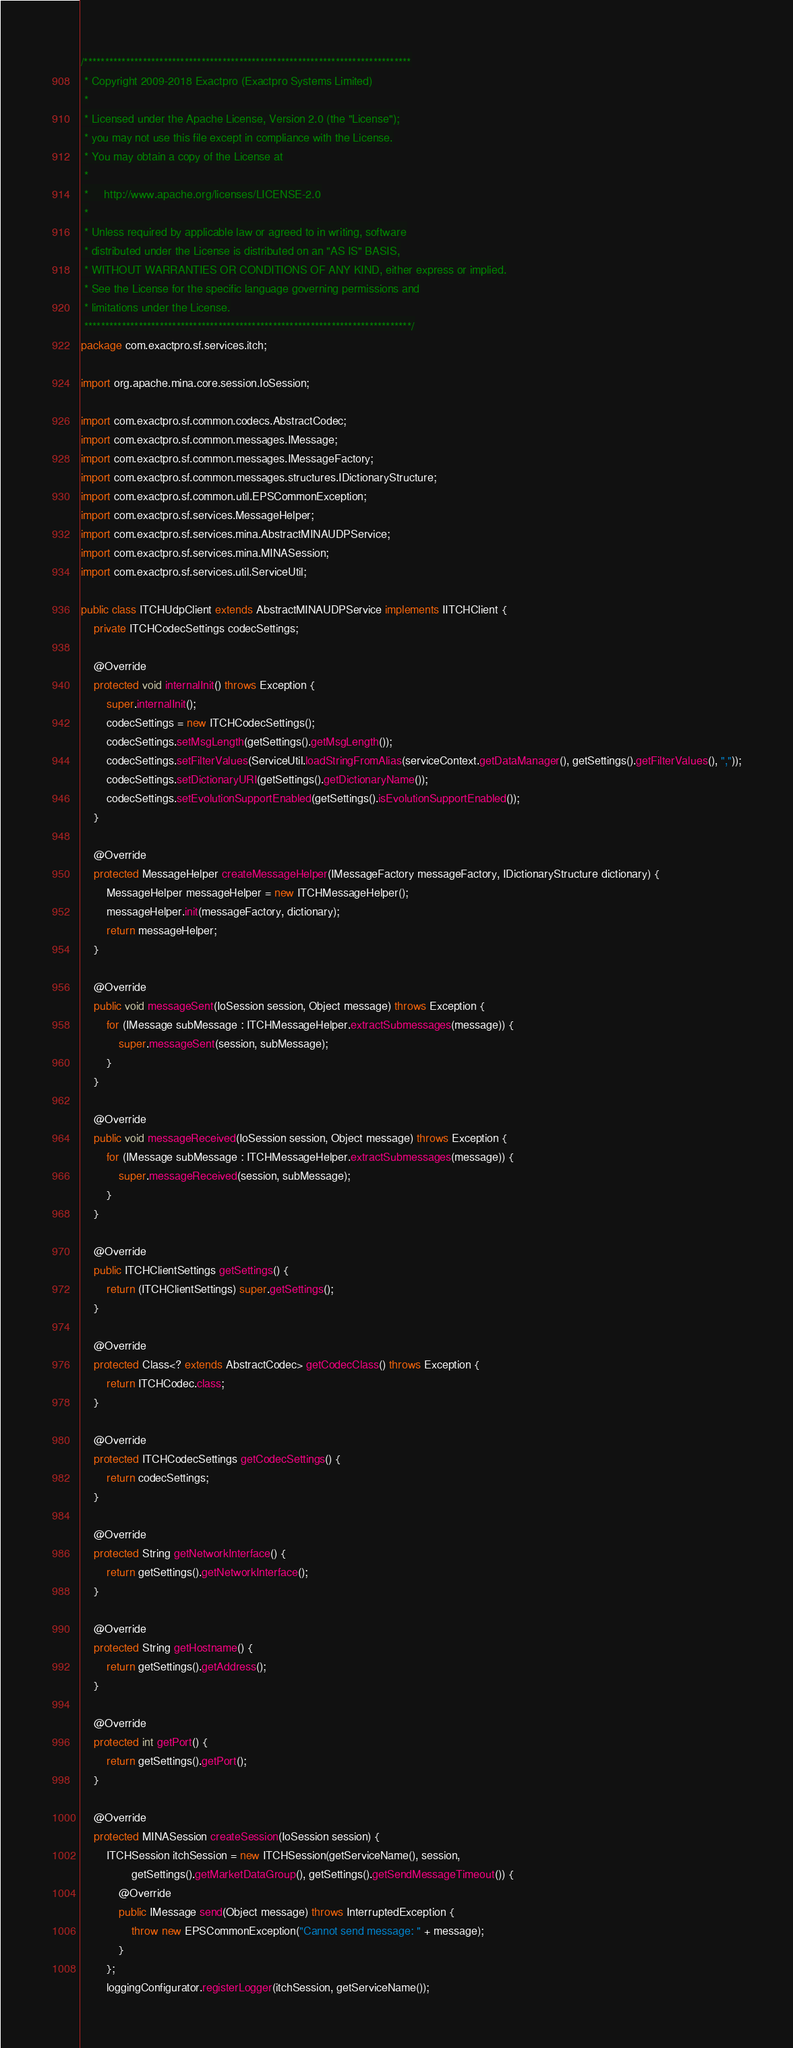Convert code to text. <code><loc_0><loc_0><loc_500><loc_500><_Java_>/******************************************************************************
 * Copyright 2009-2018 Exactpro (Exactpro Systems Limited)
 *
 * Licensed under the Apache License, Version 2.0 (the "License");
 * you may not use this file except in compliance with the License.
 * You may obtain a copy of the License at
 *
 *     http://www.apache.org/licenses/LICENSE-2.0
 *
 * Unless required by applicable law or agreed to in writing, software
 * distributed under the License is distributed on an "AS IS" BASIS,
 * WITHOUT WARRANTIES OR CONDITIONS OF ANY KIND, either express or implied.
 * See the License for the specific language governing permissions and
 * limitations under the License.
 ******************************************************************************/
package com.exactpro.sf.services.itch;

import org.apache.mina.core.session.IoSession;

import com.exactpro.sf.common.codecs.AbstractCodec;
import com.exactpro.sf.common.messages.IMessage;
import com.exactpro.sf.common.messages.IMessageFactory;
import com.exactpro.sf.common.messages.structures.IDictionaryStructure;
import com.exactpro.sf.common.util.EPSCommonException;
import com.exactpro.sf.services.MessageHelper;
import com.exactpro.sf.services.mina.AbstractMINAUDPService;
import com.exactpro.sf.services.mina.MINASession;
import com.exactpro.sf.services.util.ServiceUtil;

public class ITCHUdpClient extends AbstractMINAUDPService implements IITCHClient {
    private ITCHCodecSettings codecSettings;

    @Override
    protected void internalInit() throws Exception {
        super.internalInit();
        codecSettings = new ITCHCodecSettings();
        codecSettings.setMsgLength(getSettings().getMsgLength());
        codecSettings.setFilterValues(ServiceUtil.loadStringFromAlias(serviceContext.getDataManager(), getSettings().getFilterValues(), ","));
        codecSettings.setDictionaryURI(getSettings().getDictionaryName());
        codecSettings.setEvolutionSupportEnabled(getSettings().isEvolutionSupportEnabled());
    }

    @Override
    protected MessageHelper createMessageHelper(IMessageFactory messageFactory, IDictionaryStructure dictionary) {
        MessageHelper messageHelper = new ITCHMessageHelper();
        messageHelper.init(messageFactory, dictionary);
        return messageHelper;
    }

    @Override
    public void messageSent(IoSession session, Object message) throws Exception {
        for (IMessage subMessage : ITCHMessageHelper.extractSubmessages(message)) {
            super.messageSent(session, subMessage);
        }
    }

    @Override
    public void messageReceived(IoSession session, Object message) throws Exception {
        for (IMessage subMessage : ITCHMessageHelper.extractSubmessages(message)) {
            super.messageReceived(session, subMessage);
        }
    }

    @Override
    public ITCHClientSettings getSettings() {
        return (ITCHClientSettings) super.getSettings();
	}

    @Override
    protected Class<? extends AbstractCodec> getCodecClass() throws Exception {
        return ITCHCodec.class;
    }

    @Override
    protected ITCHCodecSettings getCodecSettings() {
        return codecSettings;
    }

    @Override
    protected String getNetworkInterface() {
        return getSettings().getNetworkInterface();
    }

    @Override
    protected String getHostname() {
        return getSettings().getAddress();
    }

    @Override
    protected int getPort() {
        return getSettings().getPort();
    }

    @Override
    protected MINASession createSession(IoSession session) {
        ITCHSession itchSession = new ITCHSession(getServiceName(), session,
                getSettings().getMarketDataGroup(), getSettings().getSendMessageTimeout()) {
            @Override
            public IMessage send(Object message) throws InterruptedException {
                throw new EPSCommonException("Cannot send message: " + message);
            }
        };
        loggingConfigurator.registerLogger(itchSession, getServiceName());</code> 